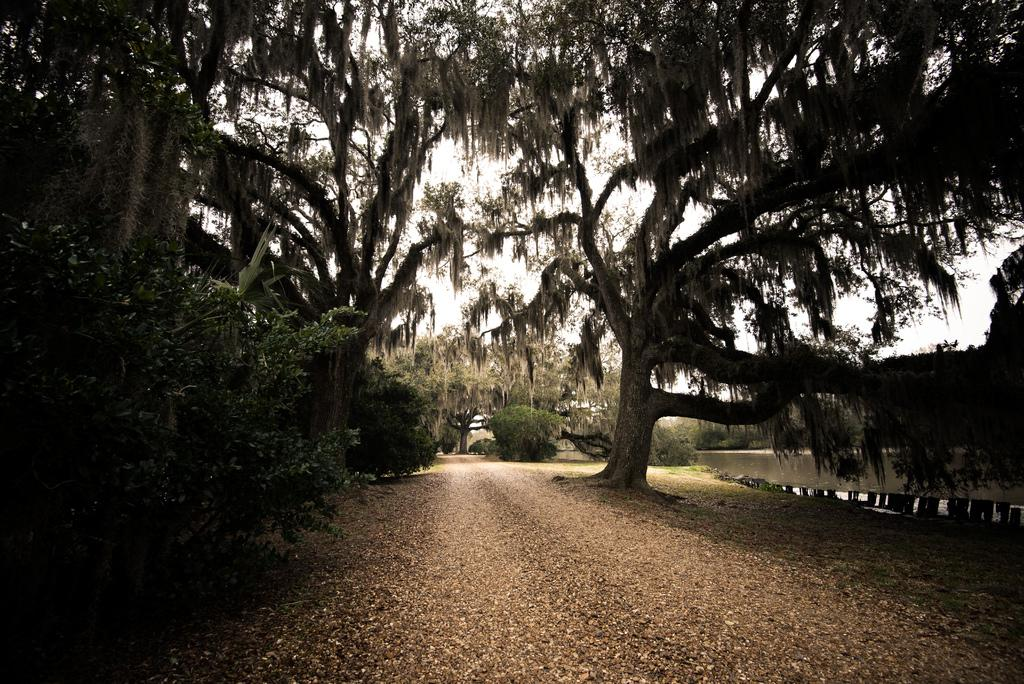What is the main subject of the image? The main subject of the image is a road. What can be seen in the background of the image? There are trees and the sky visible in the background of the image. What type of magic is being performed with the button and sock in the image? There is no button or sock present in the image, and therefore no magic can be observed. 